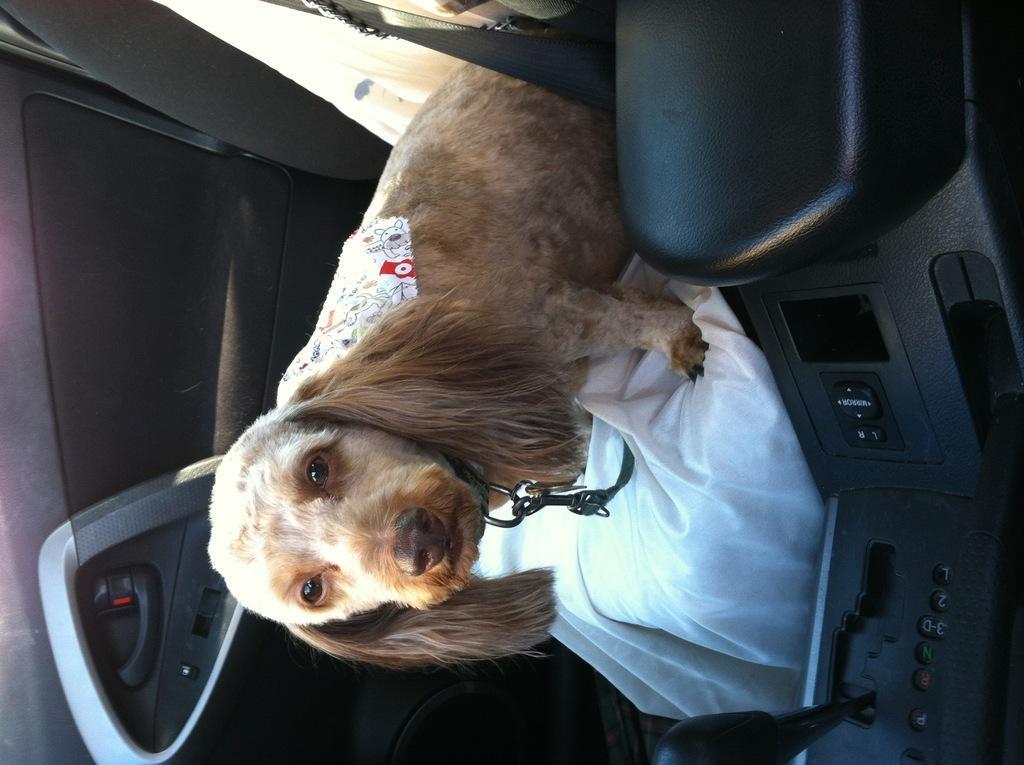In one or two sentences, can you explain what this image depicts? In this image I can see dog sitting on the car seat. 